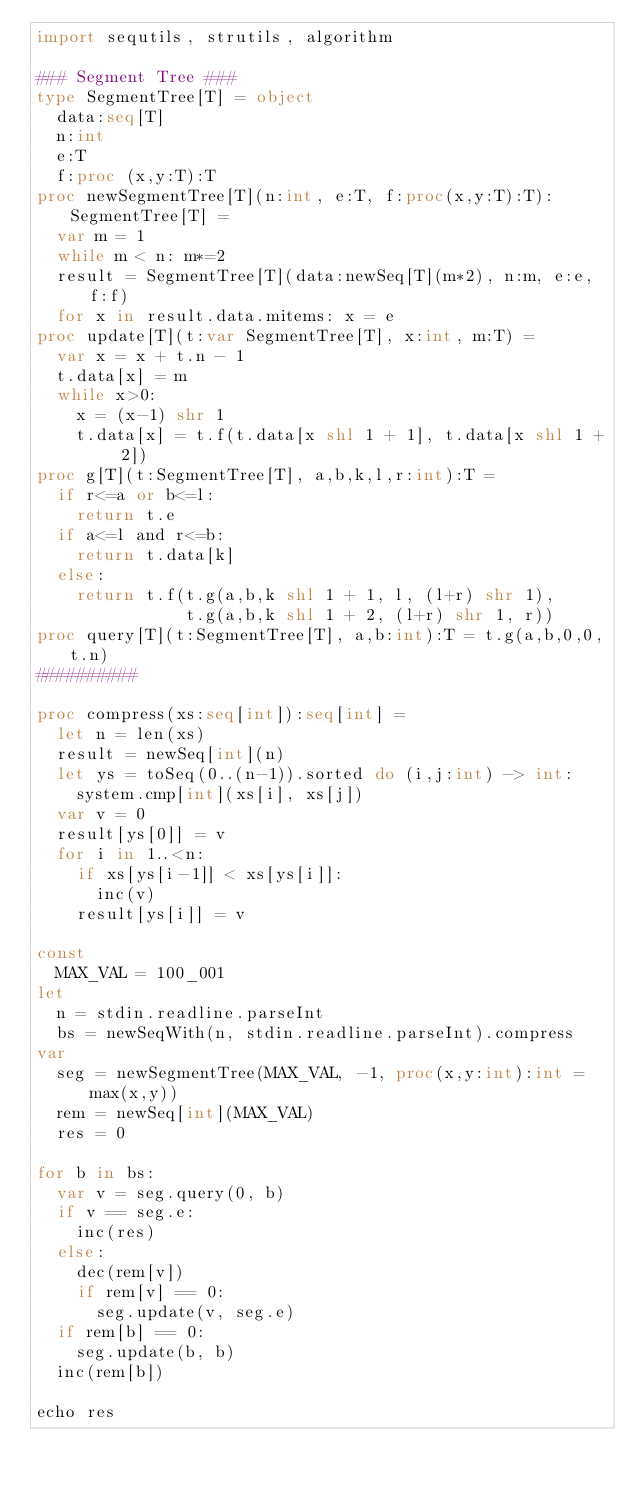<code> <loc_0><loc_0><loc_500><loc_500><_Nim_>import sequtils, strutils, algorithm

### Segment Tree ###
type SegmentTree[T] = object
  data:seq[T]
  n:int
  e:T
  f:proc (x,y:T):T
proc newSegmentTree[T](n:int, e:T, f:proc(x,y:T):T):SegmentTree[T] =
  var m = 1
  while m < n: m*=2
  result = SegmentTree[T](data:newSeq[T](m*2), n:m, e:e, f:f)
  for x in result.data.mitems: x = e
proc update[T](t:var SegmentTree[T], x:int, m:T) =
  var x = x + t.n - 1
  t.data[x] = m
  while x>0:
    x = (x-1) shr 1
    t.data[x] = t.f(t.data[x shl 1 + 1], t.data[x shl 1 + 2])
proc g[T](t:SegmentTree[T], a,b,k,l,r:int):T =
  if r<=a or b<=l:
    return t.e
  if a<=l and r<=b:
    return t.data[k]
  else:
    return t.f(t.g(a,b,k shl 1 + 1, l, (l+r) shr 1),
               t.g(a,b,k shl 1 + 2, (l+r) shr 1, r))
proc query[T](t:SegmentTree[T], a,b:int):T = t.g(a,b,0,0,t.n)
##########

proc compress(xs:seq[int]):seq[int] =
  let n = len(xs)
  result = newSeq[int](n)
  let ys = toSeq(0..(n-1)).sorted do (i,j:int) -> int:
    system.cmp[int](xs[i], xs[j])
  var v = 0
  result[ys[0]] = v
  for i in 1..<n:
    if xs[ys[i-1]] < xs[ys[i]]:
      inc(v)
    result[ys[i]] = v

const
  MAX_VAL = 100_001
let
  n = stdin.readline.parseInt
  bs = newSeqWith(n, stdin.readline.parseInt).compress
var
  seg = newSegmentTree(MAX_VAL, -1, proc(x,y:int):int = max(x,y))
  rem = newSeq[int](MAX_VAL)
  res = 0

for b in bs:
  var v = seg.query(0, b)
  if v == seg.e:
    inc(res)
  else:
    dec(rem[v])
    if rem[v] == 0:
      seg.update(v, seg.e)
  if rem[b] == 0:
    seg.update(b, b)
  inc(rem[b])
    
echo res
</code> 